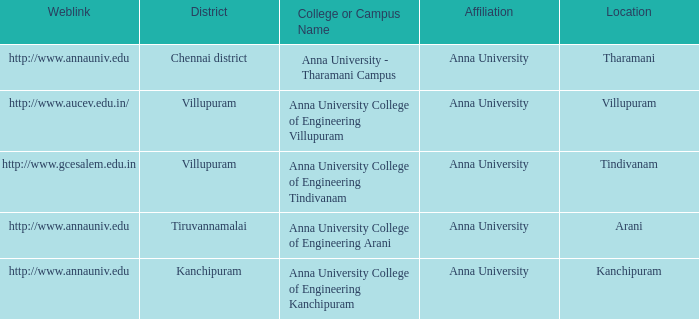What District has a College or Campus Name of anna university college of engineering kanchipuram? Kanchipuram. 